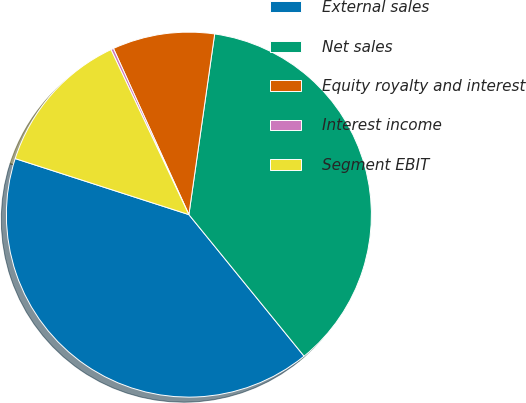<chart> <loc_0><loc_0><loc_500><loc_500><pie_chart><fcel>External sales<fcel>Net sales<fcel>Equity royalty and interest<fcel>Interest income<fcel>Segment EBIT<nl><fcel>40.84%<fcel>36.87%<fcel>9.04%<fcel>0.24%<fcel>13.01%<nl></chart> 